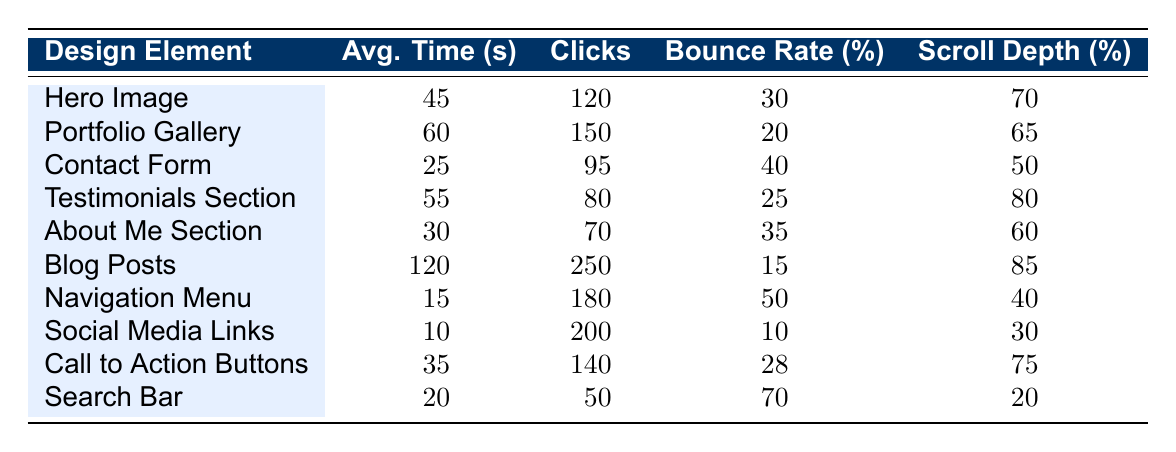What is the average time spent on the Blog Posts section? The average time spent on the Blog Posts section is explicitly listed in the table as 120 seconds.
Answer: 120 seconds Which design element has the highest bounce rate? The bounce rates for all elements are listed in the table. The highest bounce rate is 70%, associated with the Search Bar.
Answer: 70% How many clicks did the Navigation Menu receive? According to the table, the Navigation Menu had 180 clicks.
Answer: 180 clicks What is the total average time spent on the Hero Image and Testimonials Section? The average time spent on the Hero Image is 45 seconds and on the Testimonials Section is 55 seconds. Adding these gives 45 + 55 = 100 seconds.
Answer: 100 seconds Is the average time spent on the Contact Form greater than the average time spent on the About Me Section? The average time spent on the Contact Form is 25 seconds, while for the About Me Section it is 30 seconds. Thus, 25 < 30, making the statement false.
Answer: No Which design element received the fewest clicks? By reviewing the clicks for each design element, the element with the fewest clicks is the About Me Section with 70 clicks.
Answer: About Me Section If we consider the average time spent, which design element is the second highest? The Blog Posts have the highest average time spent at 120 seconds. The second highest is the Portfolio Gallery with 60 seconds.
Answer: Portfolio Gallery How does the bounce rate of Social Media Links compare to that of Blog Posts? The bounce rate for Social Media Links is 10%, and for Blog Posts, it is 15%. Thus, Social Media Links have a lower bounce rate than Blog Posts.
Answer: Lower What is the average scroll depth percentage for all design elements? The scroll depths are: 70, 65, 50, 80, 60, 85, 40, 30, 75, and 20, adding these gives 70 + 65 + 50 + 80 + 60 + 85 + 40 + 30 + 75 + 20 = 675. There are 10 elements, so the average scroll depth is 675 / 10 = 67.5%.
Answer: 67.5% Which design element has the lowest average time spent and what is that time? The average times spent are listed, and the lowest is for the Social Media Links with 10 seconds.
Answer: Social Media Links, 10 seconds What is the difference in clicks between the Blog Posts and the Contact Form? Blog Posts received 250 clicks while the Contact Form received 95 clicks. The difference is 250 - 95 = 155 clicks.
Answer: 155 clicks 